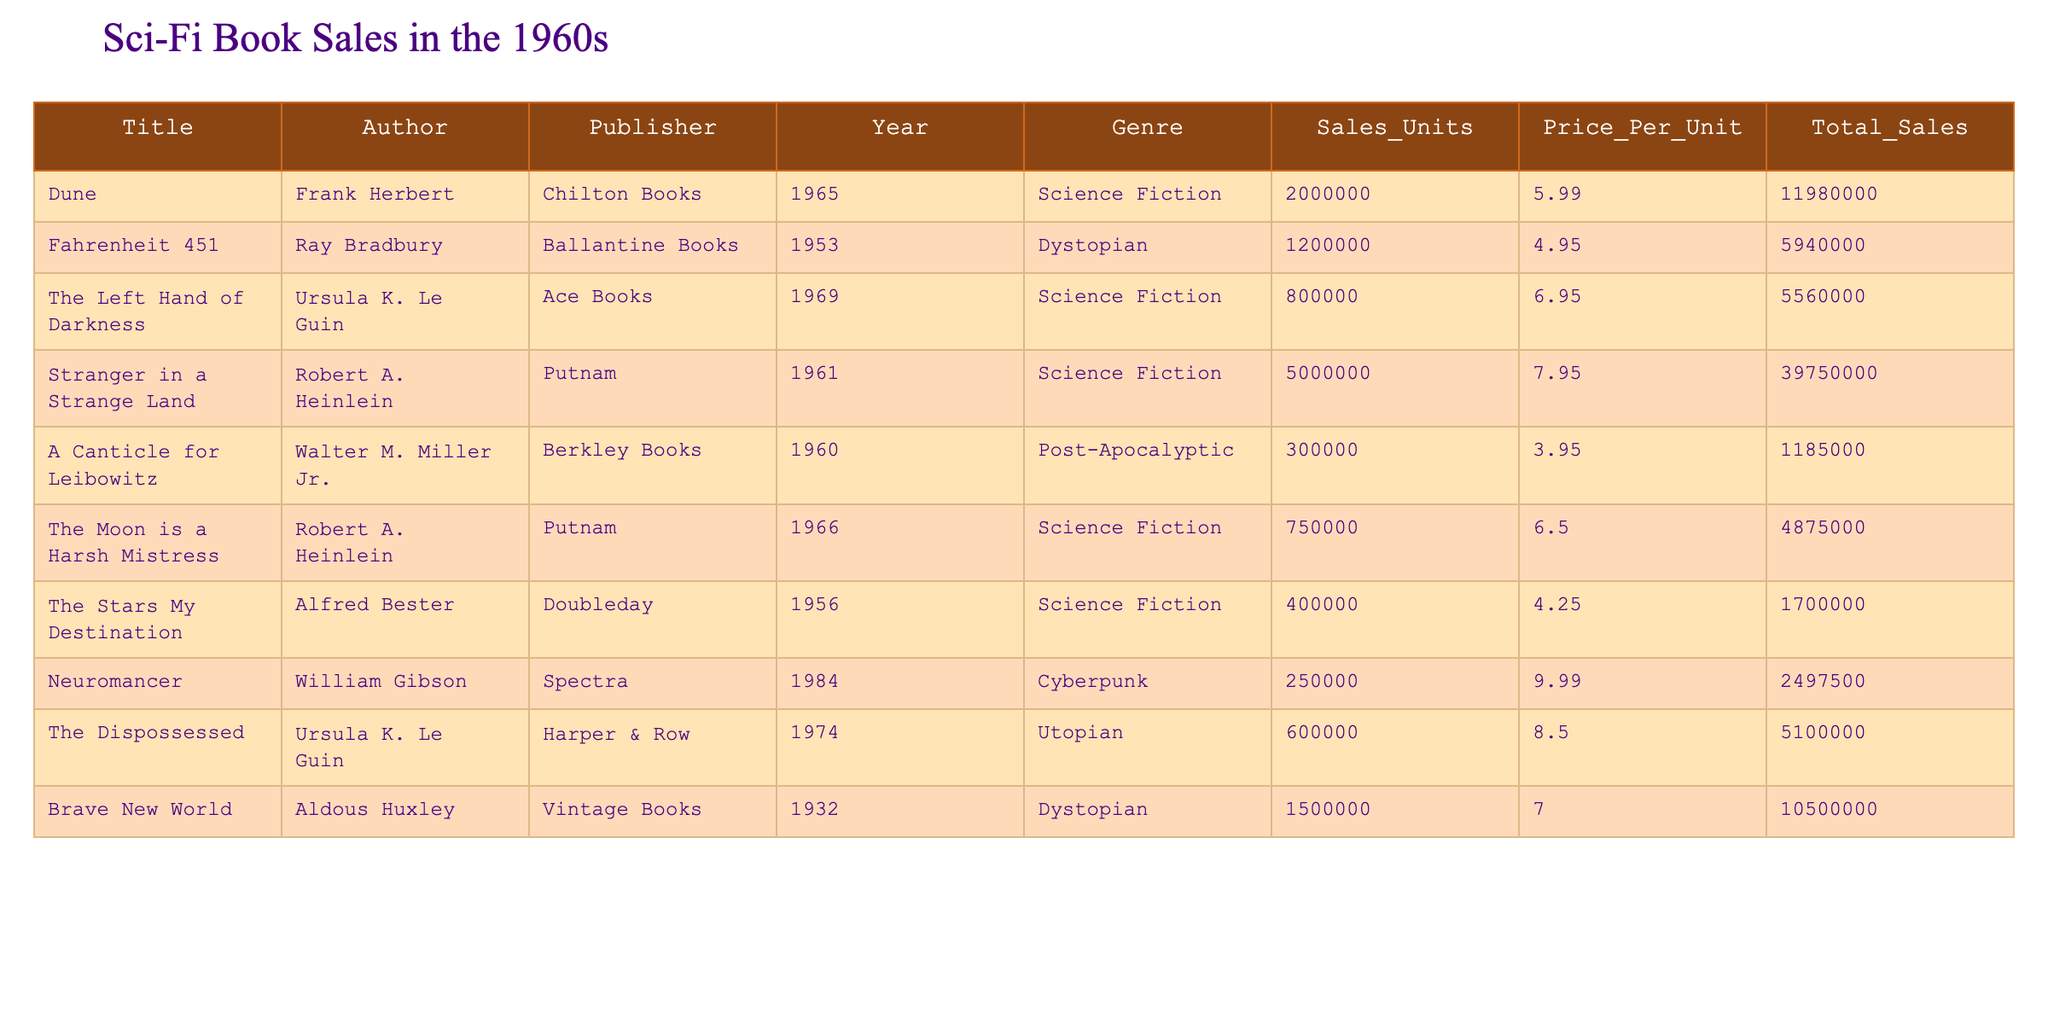What is the title of the best-selling science fiction book in the 1960s? The best-selling book is determined by the highest value in the "Sales_Units" column for the genre "Science Fiction." The title with the highest sales units is "Stranger in a Strange Land" with 5,000,000 units sold.
Answer: Stranger in a Strange Land What is the total sales amount for "Dune"? The "Total_Sales" column provides the total sales figure directly. For "Dune," the total sales amount is $11,980,000 as noted in the table.
Answer: 11,980,000 What is the average price per unit of the science fiction books listed? To calculate the average price per unit, sum the prices of all science fiction books listed and divide by the total number of those books: (5.99 + 6.95 + 7.95 + 6.50) / 4 = 6.485.
Answer: 6.485 Which author has the highest total sales among the listed books? By comparing the "Total_Sales" values for each author, Robert A. Heinlein has the highest total sales of $39,750,000 from his books.
Answer: Robert A. Heinlein Is there any science fiction book published before 1960 with total sales above 1 million units? Checking the publication year and sales for science fiction books, "Stranger in a Strange Land" (1961) and "Dune" (1965) do not qualify, but "The Stars My Destination," published in 1956, has 400,000 units sold. So the answer is no.
Answer: No What is the difference in total sales between "The Left Hand of Darkness" and "A Canticle for Leibowitz"? Total sales for "The Left Hand of Darkness" is $5,560,000 and for "A Canticle for Leibowitz" is $1,185,000. The difference is $5,560,000 - $1,185,000 = $4,375,000.
Answer: 4,375,000 Are there any dystopian novels in the table that had total sales over 5 million? "Fahrenheit 451" has total sales of $5,940,000 and "Brave New World" has $10,500,000. Since both values exceed 5 million, the answer is yes.
Answer: Yes How many total units were sold for all science fiction books combined? To find the total units for all science fiction books, sum the sales units: 2,000,000 + 800,000 + 5,000,000 + 750,000 = 8,550,000.
Answer: 8,550,000 Which book had the lowest total sales in the table? By checking the "Total_Sales" column, "A Canticle for Leibowitz" has the lowest total sales of $1,185,000.
Answer: A Canticle for Leibowitz 